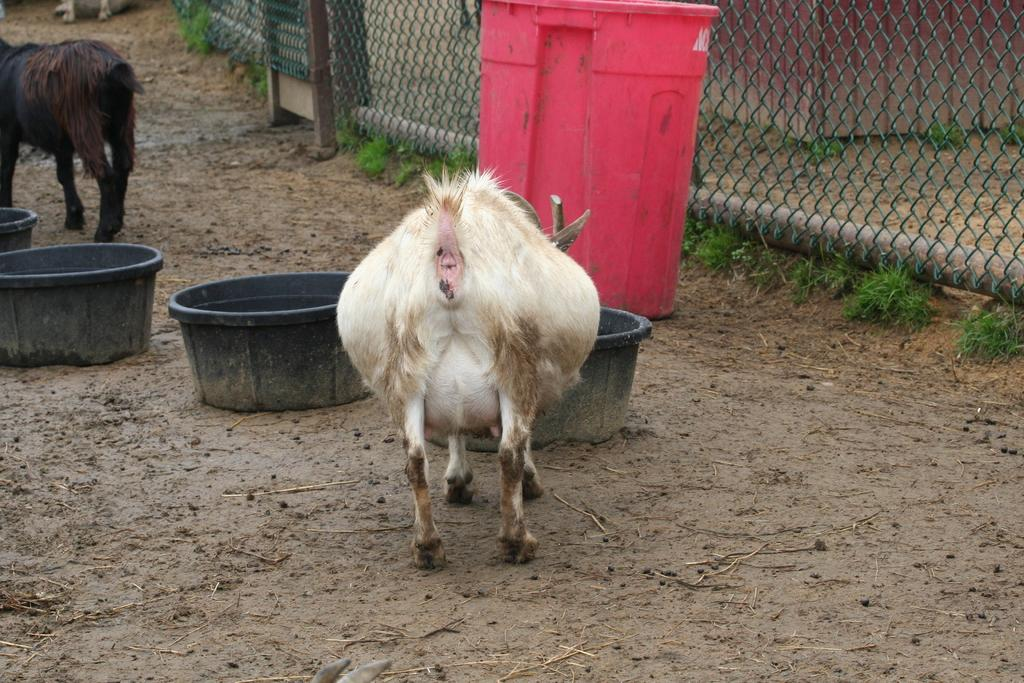What types of living organisms can be seen in the image? There are animals in the image. What kind of objects are present for storage or transportation? There are containers in the image. What is used for waste disposal in the image? There is a bin in the image. What material is used to separate or enclose certain areas in the image? There is mesh in the image. What type of vegetation is visible in the image? There is grass in the image. Can you describe any other objects present in the image? There are other objects in the image, but their specific details are not mentioned in the provided facts. What type of comb can be seen in the image? There is no comb present in the image. What color is the sky in the image? The provided facts do not mention the sky, so we cannot determine its color from the image. 